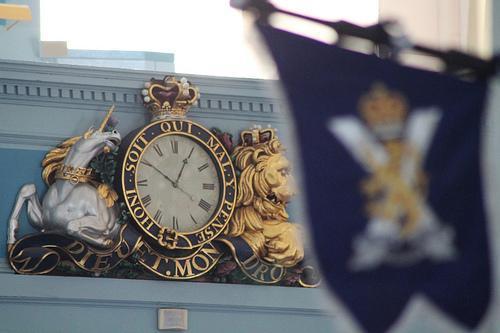How many clocks on the wall?
Give a very brief answer. 1. How many flags hanging on the building?
Give a very brief answer. 1. 